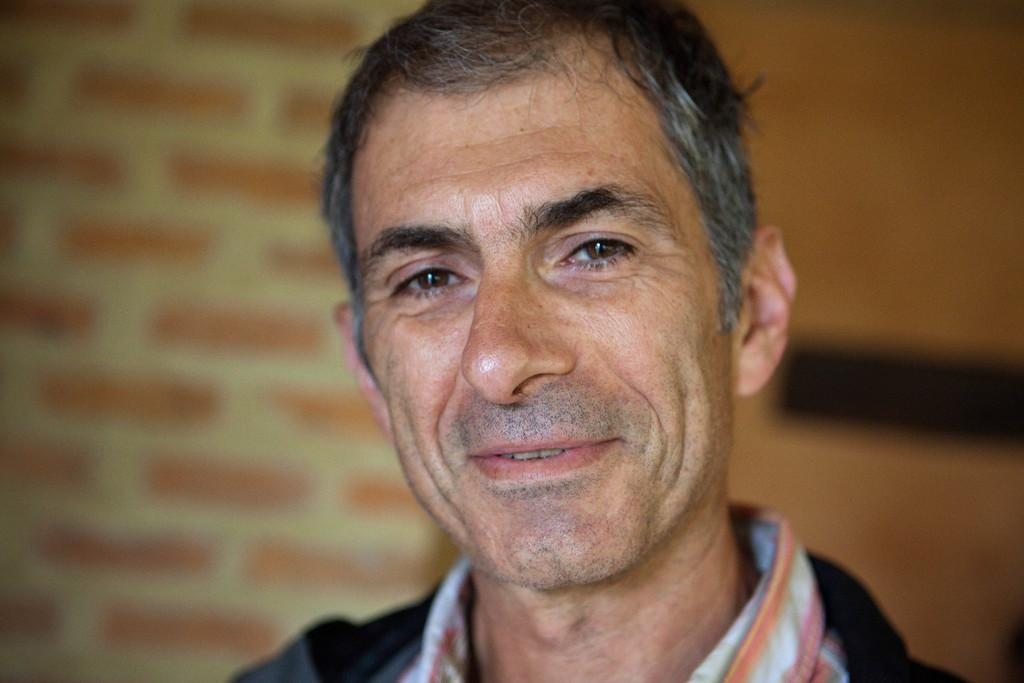Who is the main subject in the image? There is a man in the center of the image. What can be seen on the left side of the image? There is a wall on the left side of the image in the background area. What type of fang can be seen in the man's mouth in the image? There is no fang visible in the man's mouth in the image. What kind of beam is supporting the wall on the left side of the image? The image does not provide enough detail to determine the type of beam supporting the wall. 